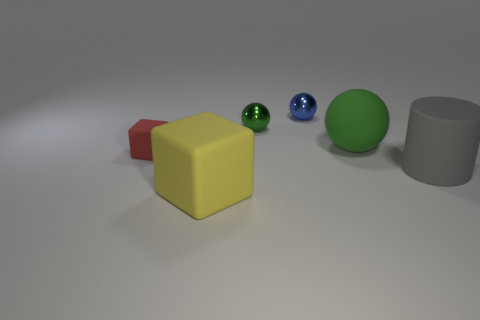There is a cylinder; does it have the same size as the rubber cube on the right side of the tiny red matte block? While it's difficult to determine the exact dimensions without a reference scale, the cylinder appears to be of a larger diameter and possibly greater height than the yellow rubber cube adjacent to the small red matte block. The cylinder's size suggests it may not be identical to the cube, but rather larger overall. 